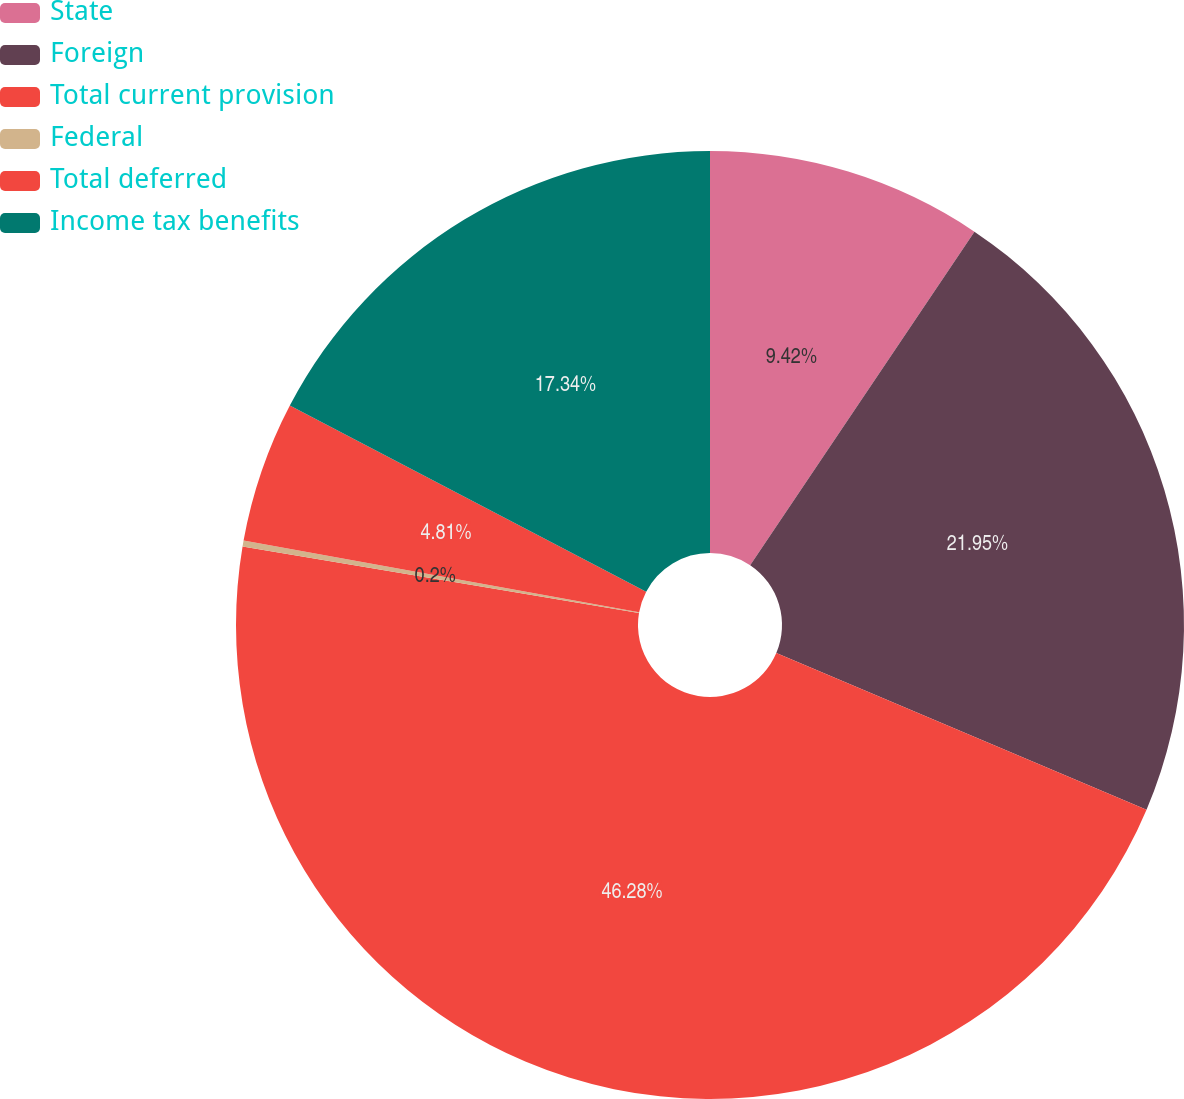<chart> <loc_0><loc_0><loc_500><loc_500><pie_chart><fcel>State<fcel>Foreign<fcel>Total current provision<fcel>Federal<fcel>Total deferred<fcel>Income tax benefits<nl><fcel>9.42%<fcel>21.95%<fcel>46.28%<fcel>0.2%<fcel>4.81%<fcel>17.34%<nl></chart> 